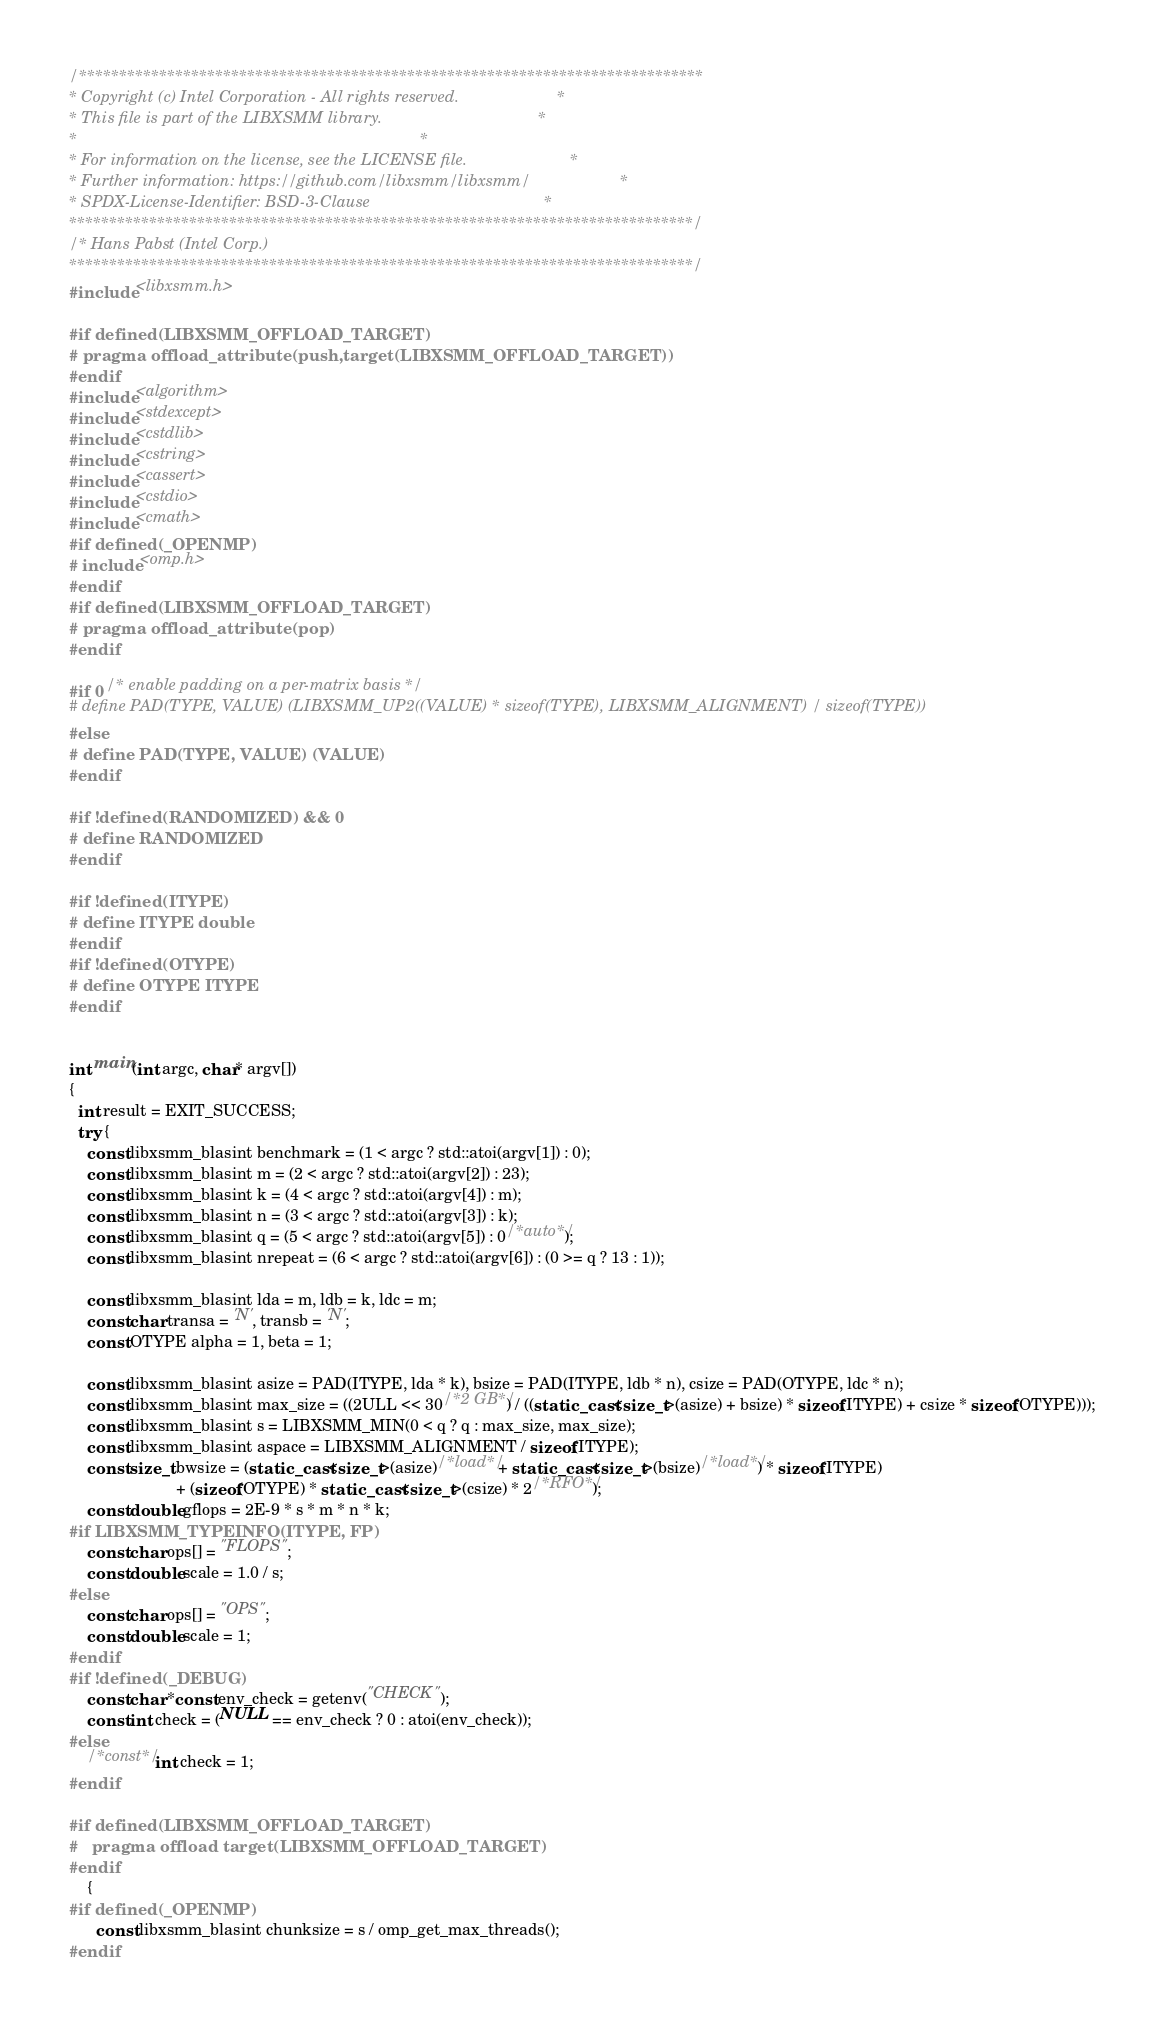Convert code to text. <code><loc_0><loc_0><loc_500><loc_500><_C++_>/******************************************************************************
* Copyright (c) Intel Corporation - All rights reserved.                      *
* This file is part of the LIBXSMM library.                                   *
*                                                                             *
* For information on the license, see the LICENSE file.                       *
* Further information: https://github.com/libxsmm/libxsmm/                    *
* SPDX-License-Identifier: BSD-3-Clause                                       *
******************************************************************************/
/* Hans Pabst (Intel Corp.)
******************************************************************************/
#include <libxsmm.h>

#if defined(LIBXSMM_OFFLOAD_TARGET)
# pragma offload_attribute(push,target(LIBXSMM_OFFLOAD_TARGET))
#endif
#include <algorithm>
#include <stdexcept>
#include <cstdlib>
#include <cstring>
#include <cassert>
#include <cstdio>
#include <cmath>
#if defined(_OPENMP)
# include <omp.h>
#endif
#if defined(LIBXSMM_OFFLOAD_TARGET)
# pragma offload_attribute(pop)
#endif

#if 0 /* enable padding on a per-matrix basis */
# define PAD(TYPE, VALUE) (LIBXSMM_UP2((VALUE) * sizeof(TYPE), LIBXSMM_ALIGNMENT) / sizeof(TYPE))
#else
# define PAD(TYPE, VALUE) (VALUE)
#endif

#if !defined(RANDOMIZED) && 0
# define RANDOMIZED
#endif

#if !defined(ITYPE)
# define ITYPE double
#endif
#if !defined(OTYPE)
# define OTYPE ITYPE
#endif


int main(int argc, char* argv[])
{
  int result = EXIT_SUCCESS;
  try {
    const libxsmm_blasint benchmark = (1 < argc ? std::atoi(argv[1]) : 0);
    const libxsmm_blasint m = (2 < argc ? std::atoi(argv[2]) : 23);
    const libxsmm_blasint k = (4 < argc ? std::atoi(argv[4]) : m);
    const libxsmm_blasint n = (3 < argc ? std::atoi(argv[3]) : k);
    const libxsmm_blasint q = (5 < argc ? std::atoi(argv[5]) : 0/*auto*/);
    const libxsmm_blasint nrepeat = (6 < argc ? std::atoi(argv[6]) : (0 >= q ? 13 : 1));

    const libxsmm_blasint lda = m, ldb = k, ldc = m;
    const char transa = 'N', transb = 'N';
    const OTYPE alpha = 1, beta = 1;

    const libxsmm_blasint asize = PAD(ITYPE, lda * k), bsize = PAD(ITYPE, ldb * n), csize = PAD(OTYPE, ldc * n);
    const libxsmm_blasint max_size = ((2ULL << 30/*2 GB*/) / ((static_cast<size_t>(asize) + bsize) * sizeof(ITYPE) + csize * sizeof(OTYPE)));
    const libxsmm_blasint s = LIBXSMM_MIN(0 < q ? q : max_size, max_size);
    const libxsmm_blasint aspace = LIBXSMM_ALIGNMENT / sizeof(ITYPE);
    const size_t bwsize = (static_cast<size_t>(asize)/*load*/ + static_cast<size_t>(bsize)/*load*/) * sizeof(ITYPE)
                        + (sizeof(OTYPE) * static_cast<size_t>(csize) * 2/*RFO*/);
    const double gflops = 2E-9 * s * m * n * k;
#if LIBXSMM_TYPEINFO(ITYPE, FP)
    const char ops[] = "FLOPS";
    const double scale = 1.0 / s;
#else
    const char ops[] = "OPS";
    const double scale = 1;
#endif
#if !defined(_DEBUG)
    const char *const env_check = getenv("CHECK");
    const int check = (NULL == env_check ? 0 : atoi(env_check));
#else
    /*const*/ int check = 1;
#endif

#if defined(LIBXSMM_OFFLOAD_TARGET)
#   pragma offload target(LIBXSMM_OFFLOAD_TARGET)
#endif
    {
#if defined(_OPENMP)
      const libxsmm_blasint chunksize = s / omp_get_max_threads();
#endif</code> 